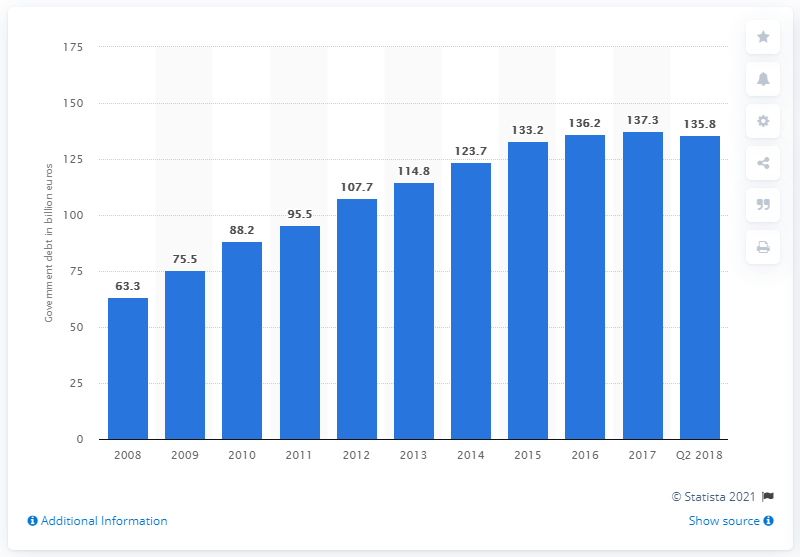Outline some significant characteristics in this image. The total amount of the Finnish government debt from 2008 to 2018 was 135.8 billion euros. 